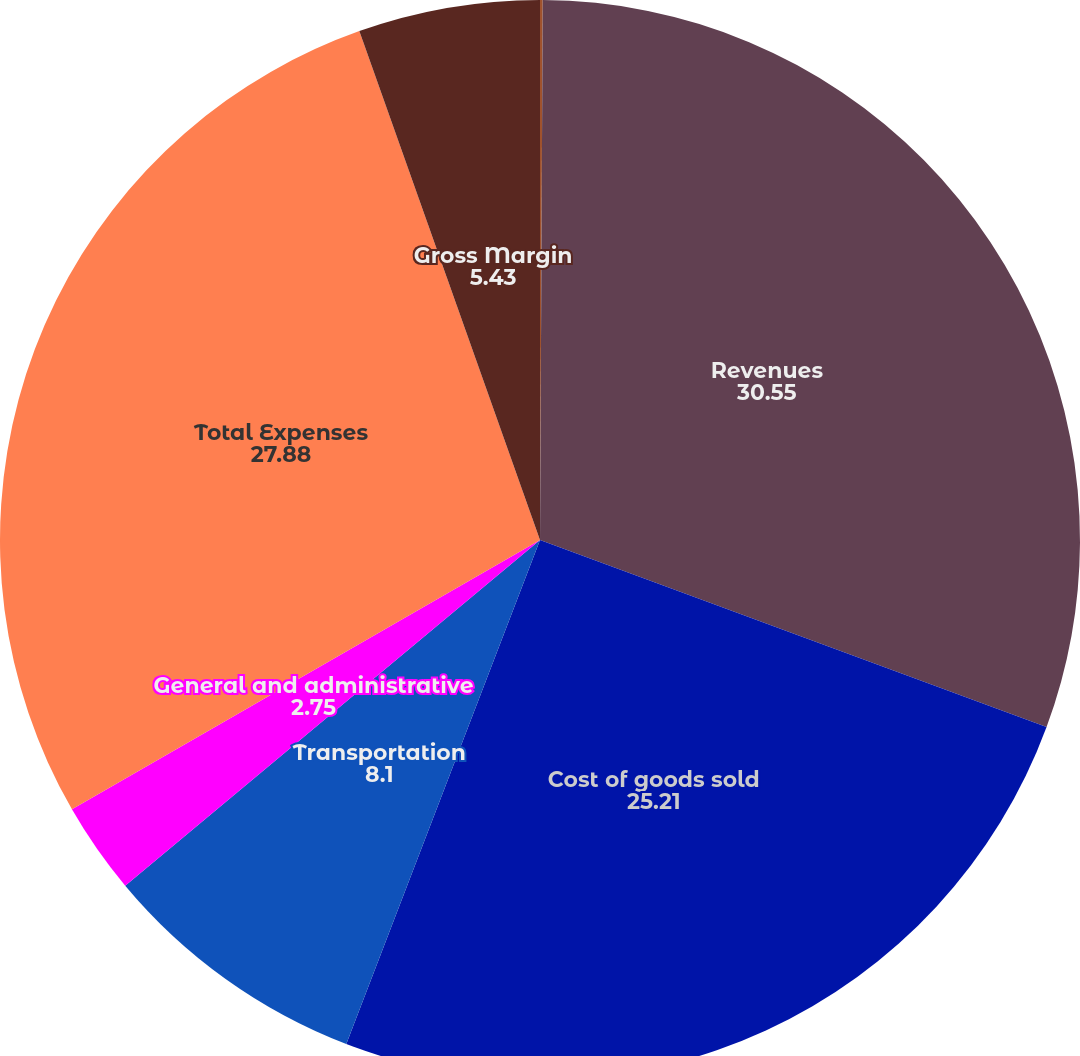<chart> <loc_0><loc_0><loc_500><loc_500><pie_chart><fcel>(in thousands)<fcel>Revenues<fcel>Cost of goods sold<fcel>Transportation<fcel>General and administrative<fcel>Total Expenses<fcel>Gross Margin<nl><fcel>0.08%<fcel>30.55%<fcel>25.21%<fcel>8.1%<fcel>2.75%<fcel>27.88%<fcel>5.43%<nl></chart> 